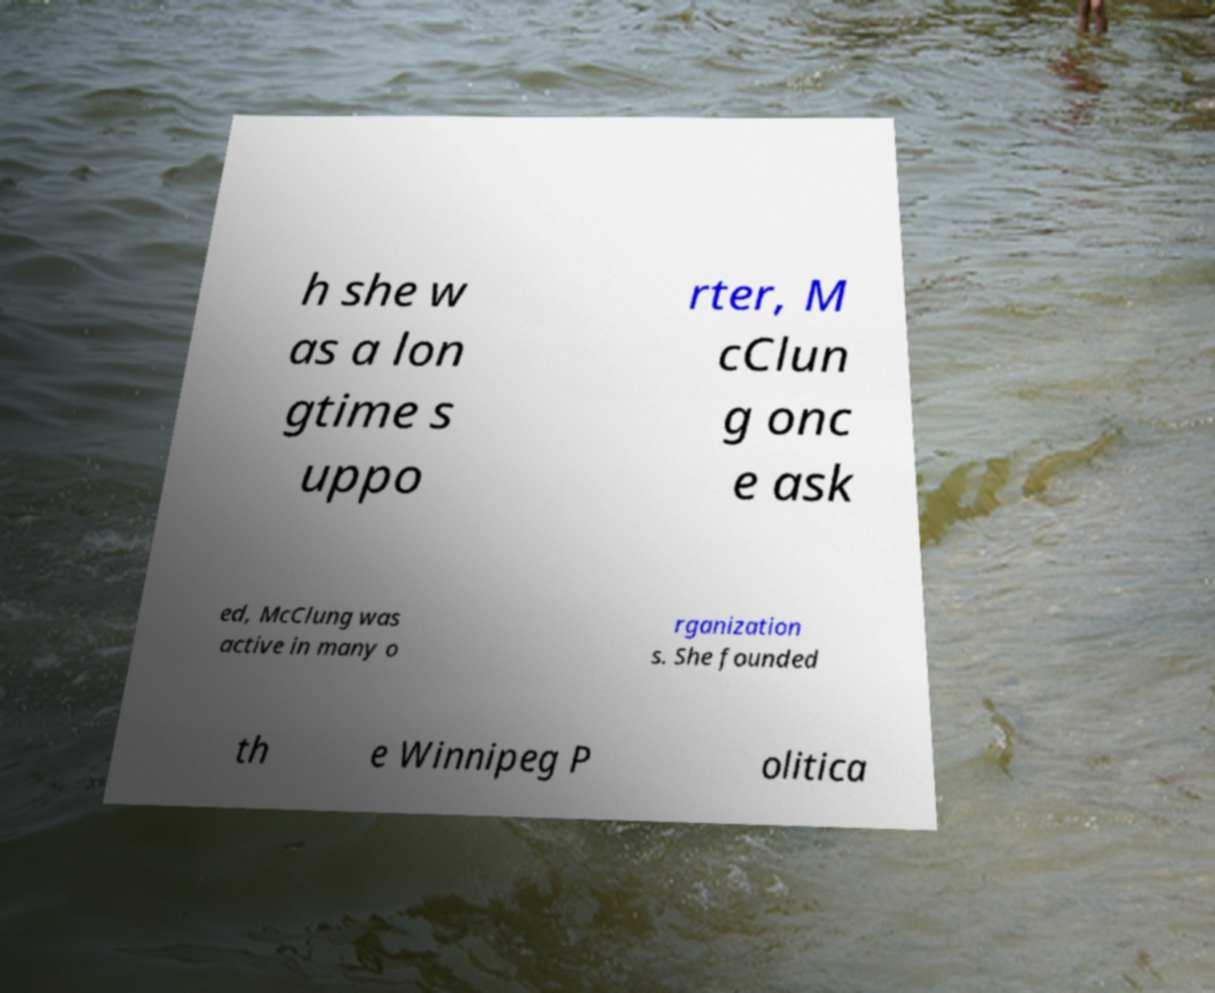There's text embedded in this image that I need extracted. Can you transcribe it verbatim? h she w as a lon gtime s uppo rter, M cClun g onc e ask ed, McClung was active in many o rganization s. She founded th e Winnipeg P olitica 